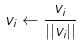<formula> <loc_0><loc_0><loc_500><loc_500>v _ { i } \leftarrow \frac { v _ { i } } { | | v _ { i } | | }</formula> 